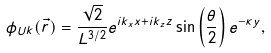Convert formula to latex. <formula><loc_0><loc_0><loc_500><loc_500>\phi _ { U k } ( \vec { r } ) = \frac { \sqrt { 2 } } { L ^ { 3 / 2 } } e ^ { i k _ { x } x + i k _ { z } z } \sin \left ( \frac { \theta } { 2 } \right ) e ^ { - \kappa y } ,</formula> 